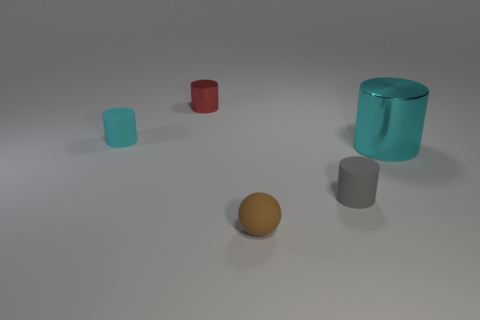What can you infer about the lighting in the scene based on the shadows of the objects? The shadows cast by the objects are relatively soft and extend towards the bottom right, suggesting a diffuse light source located towards the top left of the scene. This type of lighting is consistent with an overcast sky or a large, soft artificial light, providing a gentle illumination with low contrast, as there are no harsh shadows or strong highlights. 